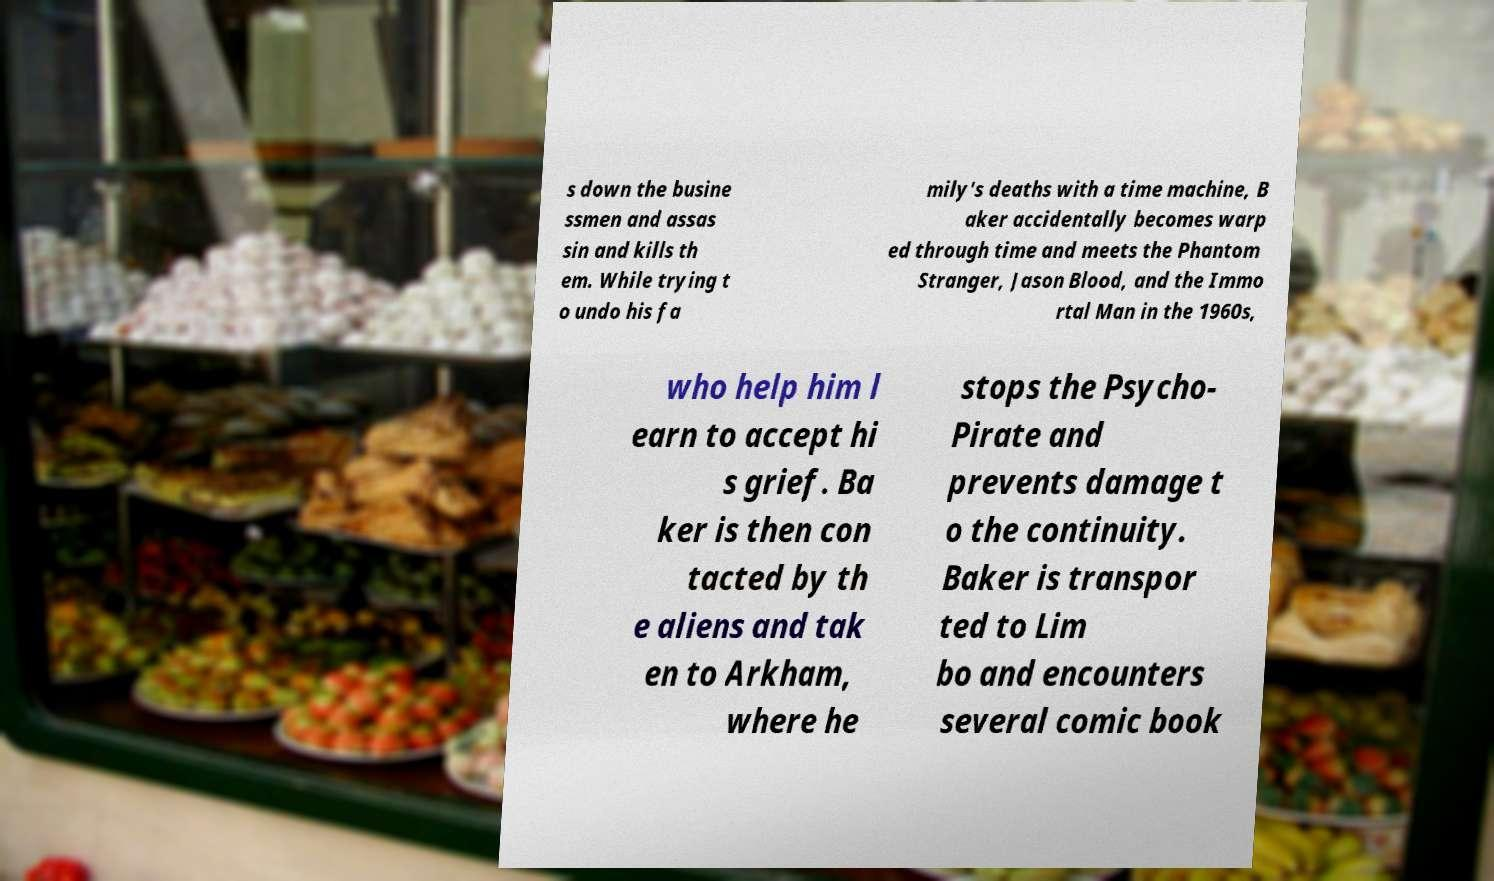Could you assist in decoding the text presented in this image and type it out clearly? s down the busine ssmen and assas sin and kills th em. While trying t o undo his fa mily's deaths with a time machine, B aker accidentally becomes warp ed through time and meets the Phantom Stranger, Jason Blood, and the Immo rtal Man in the 1960s, who help him l earn to accept hi s grief. Ba ker is then con tacted by th e aliens and tak en to Arkham, where he stops the Psycho- Pirate and prevents damage t o the continuity. Baker is transpor ted to Lim bo and encounters several comic book 